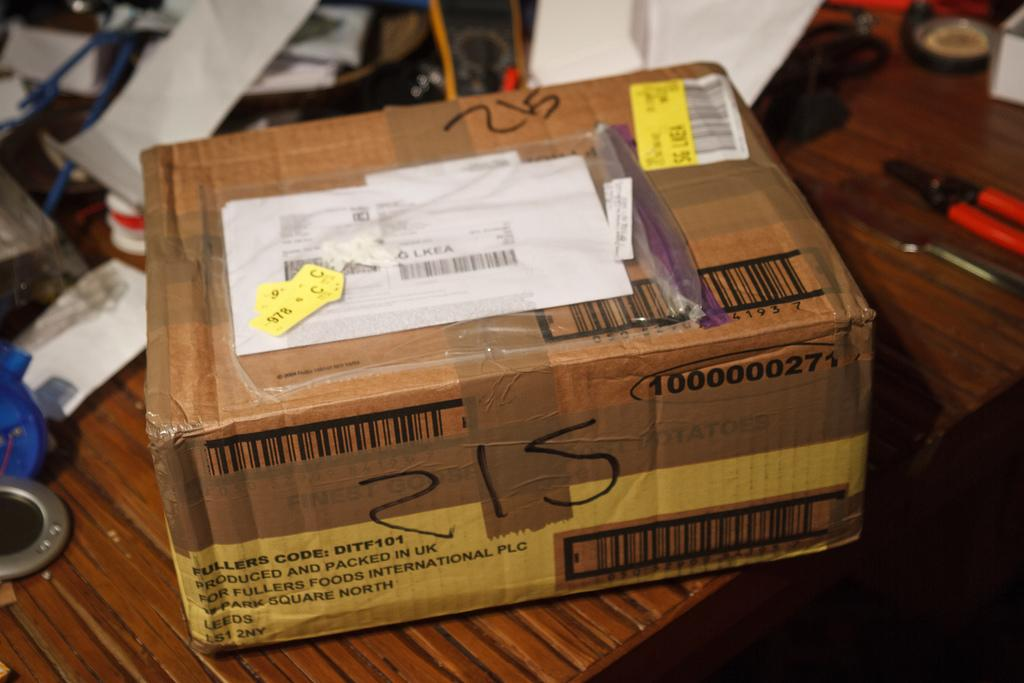What is the main object in the center of the image? There is a cartoon box in the center of the image. What else can be seen in the image besides the cartoon box? There are papers, tools, and wires in the image. Where are the papers, tools, and wires located? The papers, tools, and wires are placed on a table. What type of straw is being used to cut the cup in the image? There is no straw or cup present in the image; it only features a cartoon box, papers, tools, and wires on a table. 